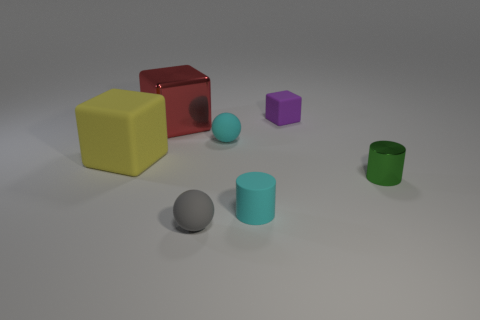Add 1 large matte cubes. How many objects exist? 8 Subtract all blocks. How many objects are left? 4 Add 1 cyan rubber cylinders. How many cyan rubber cylinders are left? 2 Add 7 big purple shiny cylinders. How many big purple shiny cylinders exist? 7 Subtract 1 green cylinders. How many objects are left? 6 Subtract all large green things. Subtract all large objects. How many objects are left? 5 